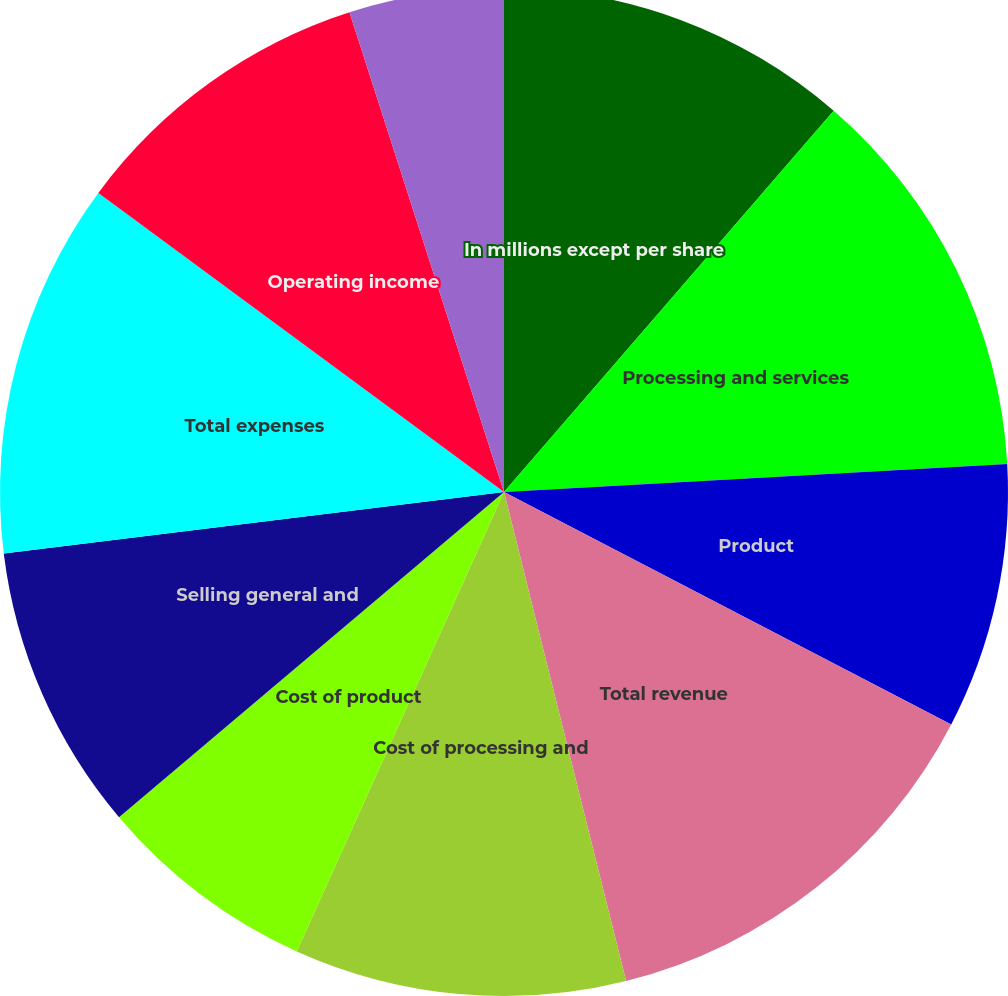Convert chart to OTSL. <chart><loc_0><loc_0><loc_500><loc_500><pie_chart><fcel>In millions except per share<fcel>Processing and services<fcel>Product<fcel>Total revenue<fcel>Cost of processing and<fcel>Cost of product<fcel>Selling general and<fcel>Total expenses<fcel>Operating income<fcel>Interest expense<nl><fcel>11.35%<fcel>12.77%<fcel>8.51%<fcel>13.48%<fcel>10.64%<fcel>7.09%<fcel>9.22%<fcel>12.06%<fcel>9.93%<fcel>4.96%<nl></chart> 